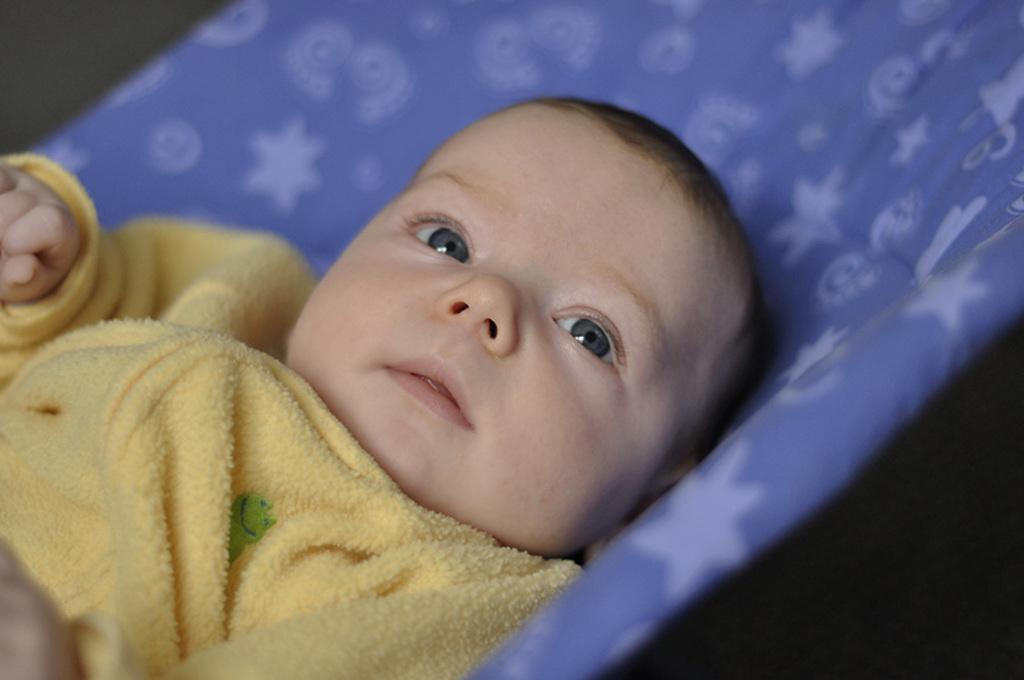What is the main subject of the picture? The main subject of the picture is an infant. What is the infant lying on? The infant is lying on a blue blanket. In which direction is the infant looking? The infant is looking to the right side. Can you describe the background of the image? The backdrop is blurred. How many wax ladybugs can be seen on the blue blanket in the image? There are no wax ladybugs present in the image. 